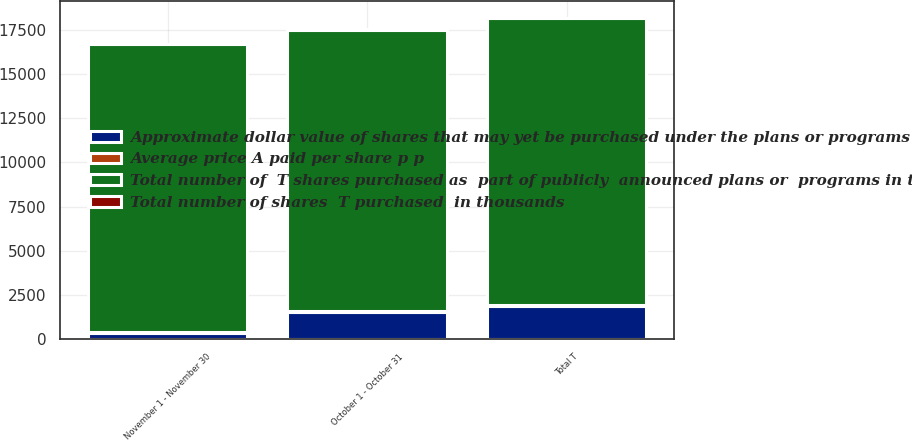Convert chart. <chart><loc_0><loc_0><loc_500><loc_500><stacked_bar_chart><ecel><fcel>October 1 - October 31<fcel>November 1 - November 30<fcel>Total T<nl><fcel>Approximate dollar value of shares that may yet be purchased under the plans or programs in millions<fcel>1522<fcel>341<fcel>1863<nl><fcel>Average price A paid per share p p<fcel>74.37<fcel>77.77<fcel>74.99<nl><fcel>Total number of  T shares purchased as  part of publicly  announced plans or  programs in thousands<fcel>15916<fcel>16257<fcel>16257<nl><fcel>Total number of shares  T purchased  in thousands<fcel>28<fcel>2<fcel>2<nl></chart> 